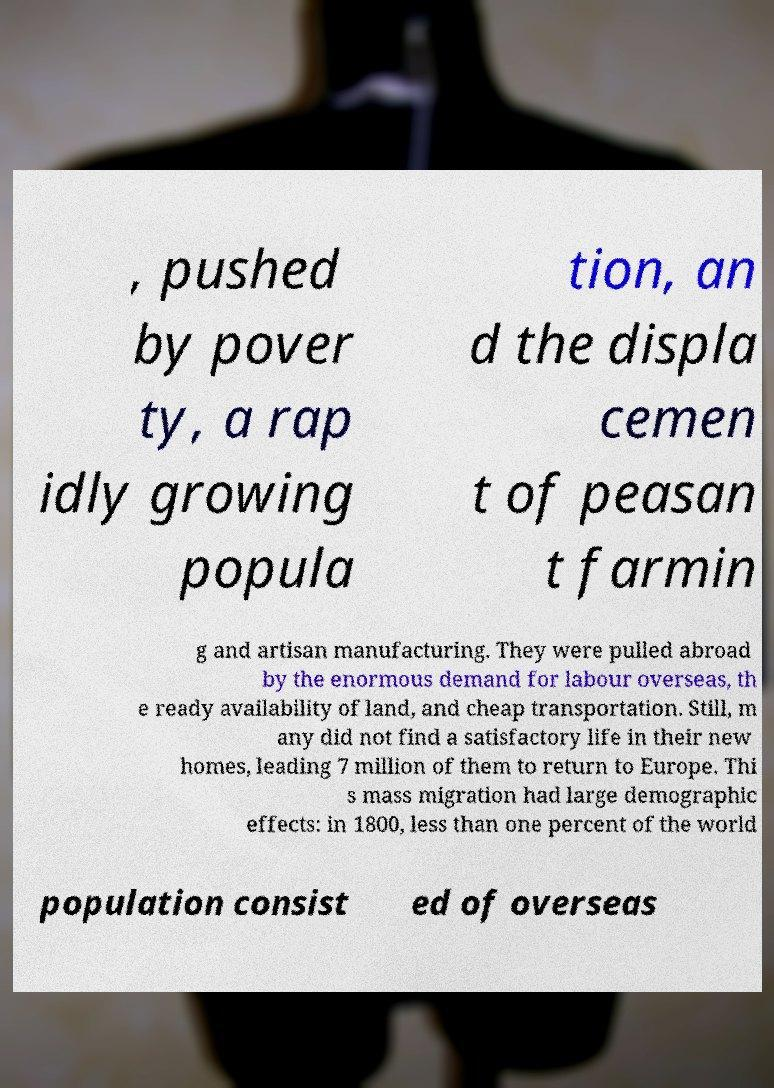Can you read and provide the text displayed in the image?This photo seems to have some interesting text. Can you extract and type it out for me? , pushed by pover ty, a rap idly growing popula tion, an d the displa cemen t of peasan t farmin g and artisan manufacturing. They were pulled abroad by the enormous demand for labour overseas, th e ready availability of land, and cheap transportation. Still, m any did not find a satisfactory life in their new homes, leading 7 million of them to return to Europe. Thi s mass migration had large demographic effects: in 1800, less than one percent of the world population consist ed of overseas 